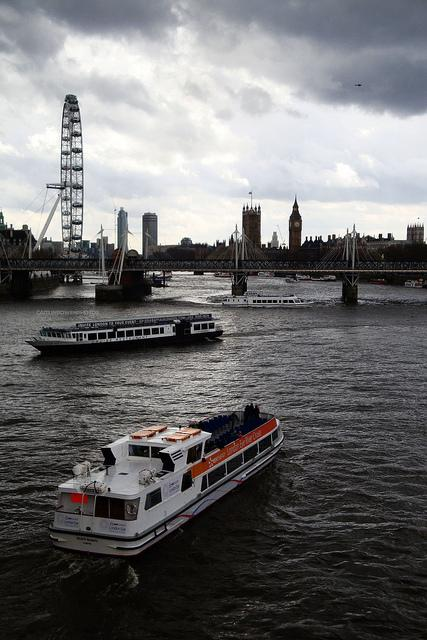What problem will the people on the ferry face? bridge 